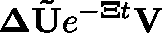Convert formula to latex. <formula><loc_0><loc_0><loc_500><loc_500>\Delta \tilde { U } e ^ { - \mathbf { \Xi } t } V</formula> 